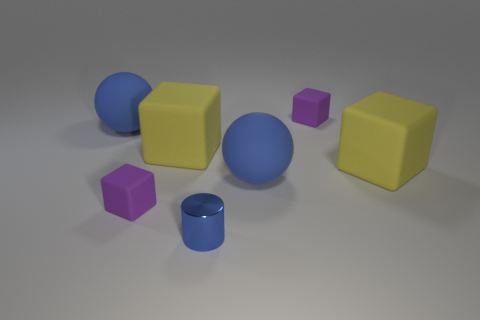What is the material of the yellow object that is left of the tiny matte object that is to the right of the tiny cylinder?
Offer a terse response. Rubber. How many things are tiny blue metallic objects or large blue rubber objects to the right of the metal thing?
Make the answer very short. 2. What number of red objects are either tiny things or metallic cylinders?
Make the answer very short. 0. Is there anything else that has the same material as the cylinder?
Give a very brief answer. No. Do the big blue thing to the right of the small blue metallic object and the tiny thing that is right of the metallic object have the same shape?
Provide a short and direct response. No. What number of yellow matte blocks are there?
Ensure brevity in your answer.  2. Are there any other things that are the same color as the small cylinder?
Provide a short and direct response. Yes. Does the tiny metal object have the same color as the sphere to the right of the small blue metal cylinder?
Offer a very short reply. Yes. Is the number of yellow blocks that are right of the blue cylinder less than the number of tiny brown shiny cylinders?
Ensure brevity in your answer.  No. There is a purple block that is left of the cylinder; what is it made of?
Your response must be concise. Rubber. 